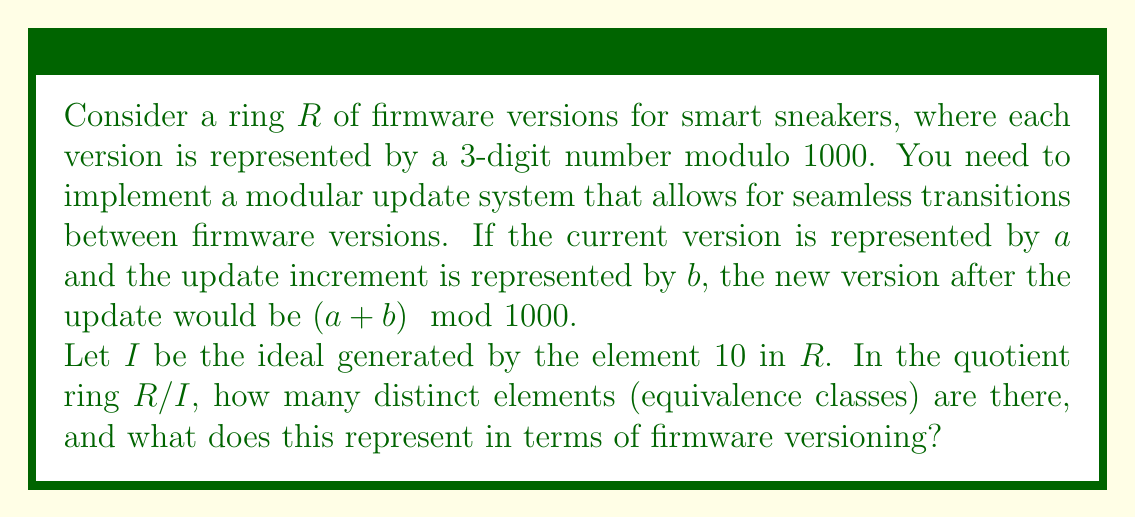Teach me how to tackle this problem. To solve this problem, we need to understand the structure of the quotient ring $R/I$:

1) First, let's consider the ring $R$. It consists of all integers from 0 to 999, with addition and multiplication performed modulo 1000.

2) The ideal $I$ generated by 10 in $R$ consists of all multiples of 10 in $R$:
   $I = \{0, 10, 20, 30, ..., 990\}$

3) In the quotient ring $R/I$, two elements of $R$ are in the same equivalence class if their difference is in $I$. In other words, two firmware versions are equivalent if they differ by a multiple of 10.

4) To count the number of distinct equivalence classes in $R/I$, we need to count how many elements of $R$ are not equivalent to each other under this relation.

5) We can see that the elements 0, 1, 2, ..., 9 each represent a distinct equivalence class, as none of these differ by a multiple of 10.

6) Any element of $R$ can be written in the form $10q + r$, where $0 \leq r < 10$. All elements with the same $r$ will be in the same equivalence class.

7) Therefore, there are exactly 10 distinct equivalence classes in $R/I$, represented by the remainders when dividing by 10.

In terms of firmware versioning, this means that the quotient ring $R/I$ effectively groups firmware versions into 10 categories based on their ones digit. This could be useful for implementing a coarse-grained update system where minor updates (changes in the ones digit) are treated as equivalent, while more significant updates (changes in the tens or hundreds digits) are distinguished.
Answer: There are 10 distinct elements (equivalence classes) in the quotient ring $R/I$. This represents a grouping of firmware versions into 10 categories based on their ones digit, allowing for a coarse-grained update system. 